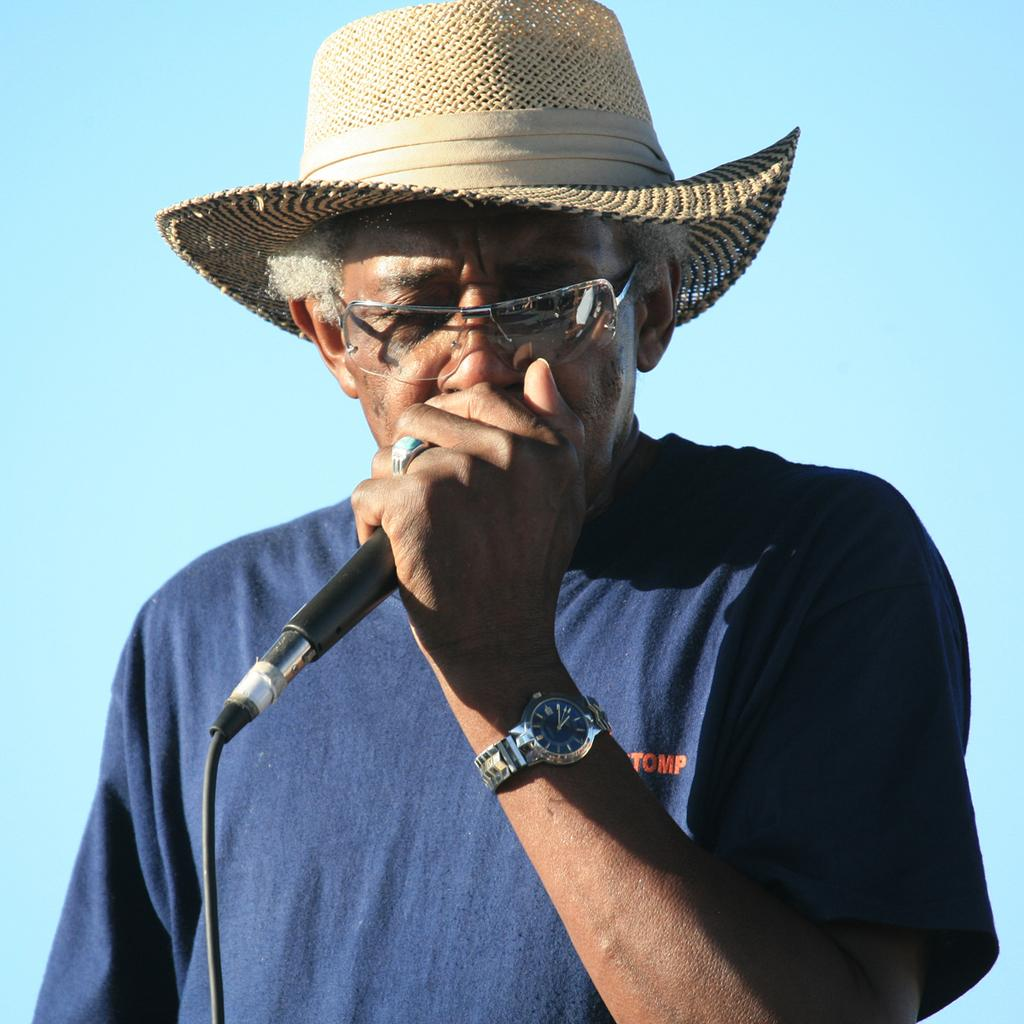What is the main subject of the image? The main subject of the image is a man. Can you describe the man's appearance in the image? The man is wearing spectacles, a cap, and a watch in the image. What is the man holding in his hand? The man is holding a microphone in his hand. What type of destruction can be seen happening in the image? There is no destruction present in the image; it features a man holding a microphone. Can you tell me how many airplanes are visible in the image? There are no airplanes present in the image. What is the man doing in the image that might cause him to sneeze? There is no indication in the image that the man is about to sneeze or that there is anything that might cause him to sneeze. 